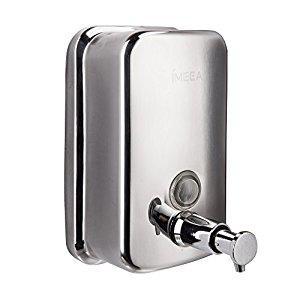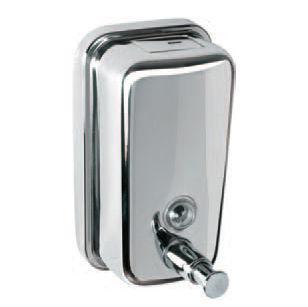The first image is the image on the left, the second image is the image on the right. Analyze the images presented: Is the assertion "The two dispensers in the paired images appear to face toward each other." valid? Answer yes or no. No. 